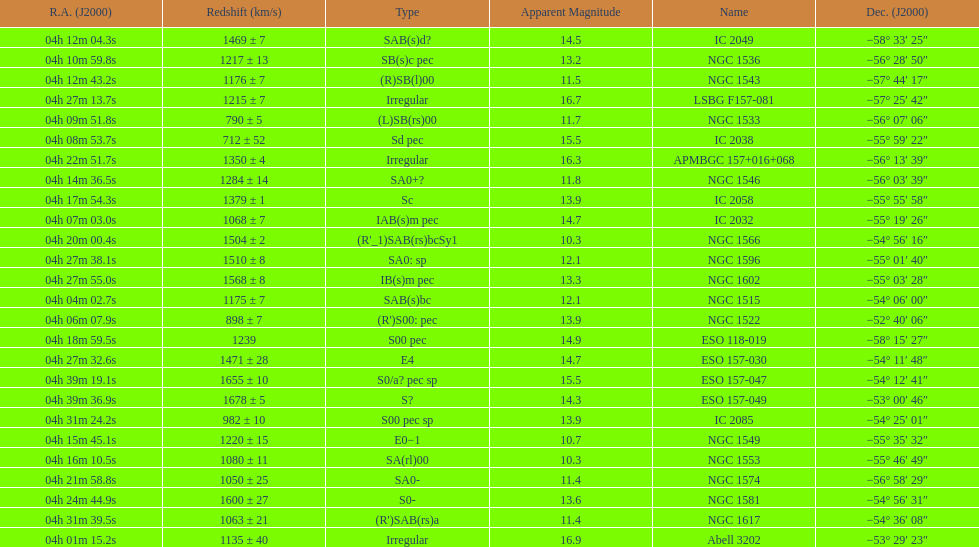Name the member with the highest apparent magnitude. Abell 3202. 